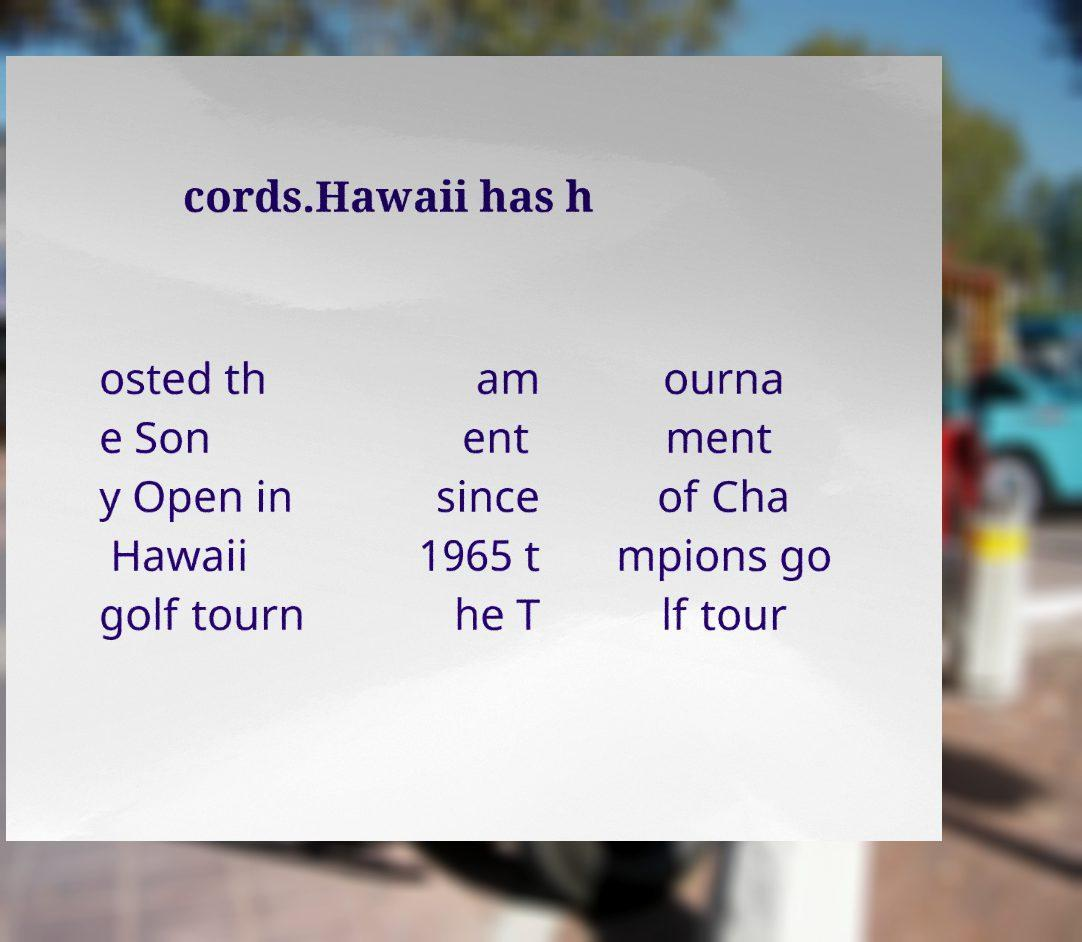What messages or text are displayed in this image? I need them in a readable, typed format. cords.Hawaii has h osted th e Son y Open in Hawaii golf tourn am ent since 1965 t he T ourna ment of Cha mpions go lf tour 